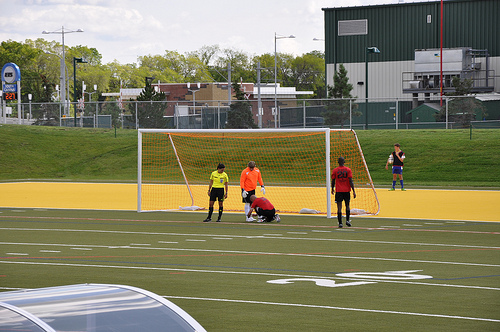<image>
Can you confirm if the boy is behind the grass? No. The boy is not behind the grass. From this viewpoint, the boy appears to be positioned elsewhere in the scene. 